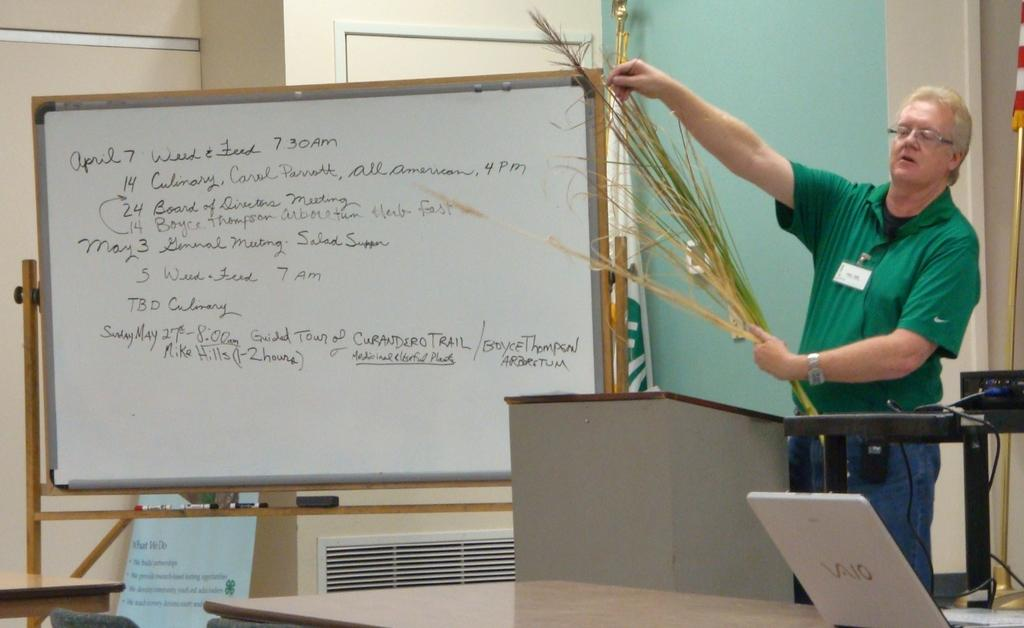What is the main subject of the image? A: The main subject of the image is a man. Can you describe the man's position in the image? The man is standing on the floor. What can be seen on the man's face in the image? The man is wearing spectacles. What objects are present in the image besides the man? There is a board, a table, and a laptop in the image. What is visible in the background of the image? There is a wall in the background of the image. What color is the sky in the image? There is no sky visible in the image; it is an indoor setting with a wall in the background. What type of bead is the man using to type on the laptop? There is no bead present in the image, and the man is not typing on the laptop. 